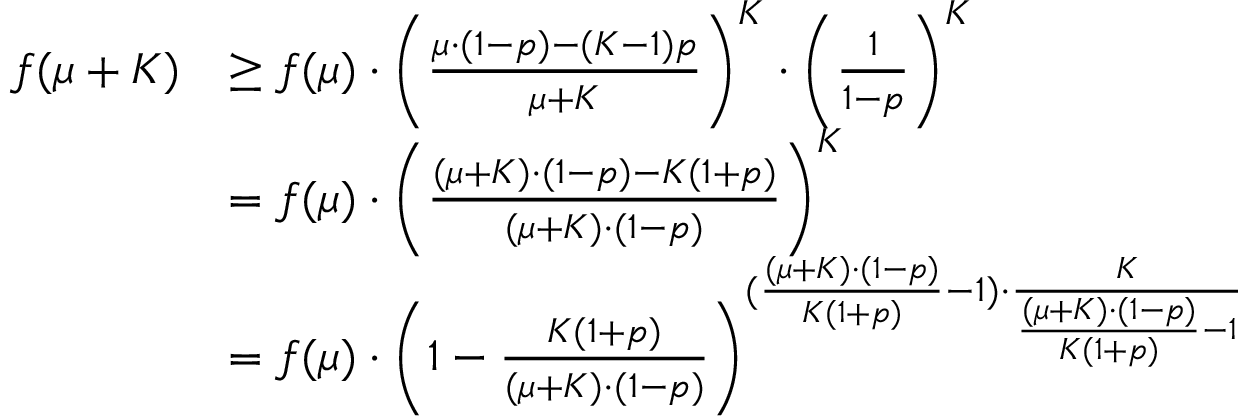<formula> <loc_0><loc_0><loc_500><loc_500>\begin{array} { r l } { f ( \mu + K ) } & { \geq f ( \mu ) \cdot \left ( \frac { \mu \cdot ( 1 - p ) - ( K - 1 ) p } { \mu + K } \right ) ^ { K } \cdot \left ( \frac { 1 } { 1 - p } \right ) ^ { K } } \\ & { = f ( \mu ) \cdot \left ( \frac { ( \mu + K ) \cdot ( 1 - p ) - K ( 1 + p ) } { ( \mu + K ) \cdot ( 1 - p ) } \right ) ^ { K } } \\ & { = f ( \mu ) \cdot \left ( 1 - \frac { K ( 1 + p ) } { ( \mu + K ) \cdot ( 1 - p ) } \right ) ^ { ( \frac { ( \mu + K ) \cdot ( 1 - p ) } { K ( 1 + p ) } - 1 ) \cdot \frac { K } { \frac { ( \mu + K ) \cdot ( 1 - p ) } { K ( 1 + p ) } - 1 } } } \end{array}</formula> 